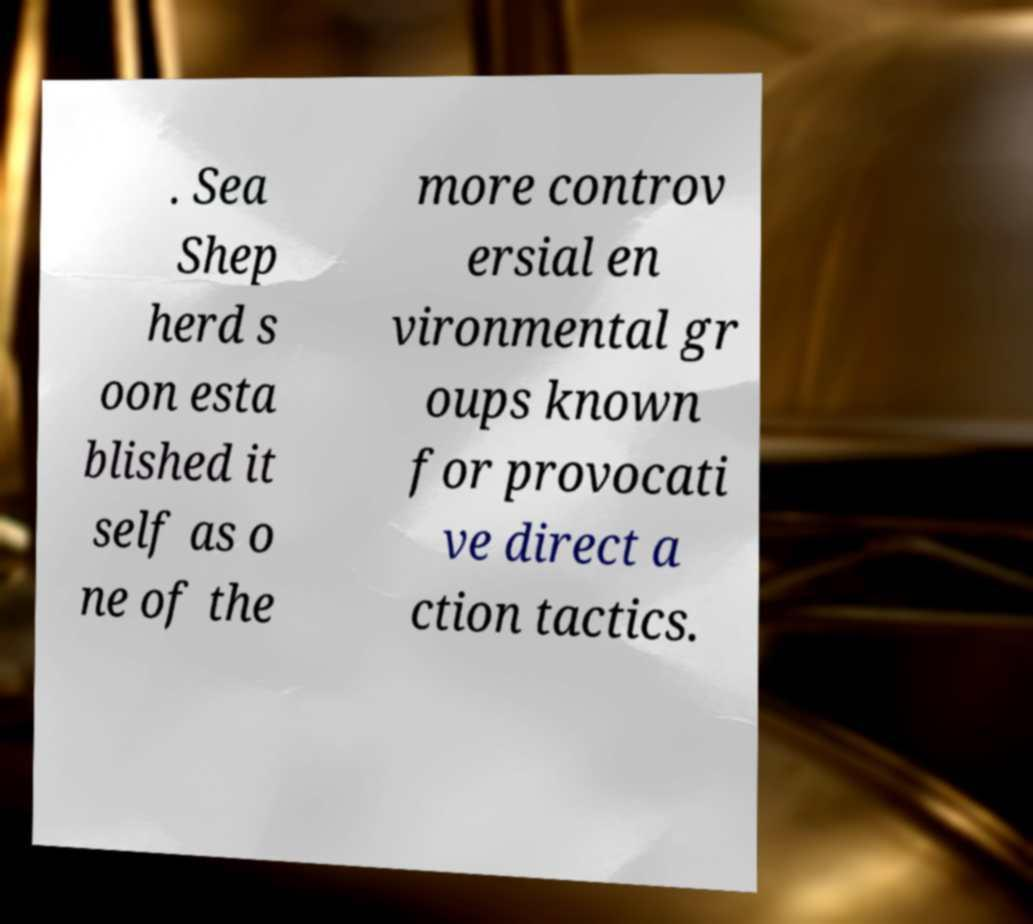Please identify and transcribe the text found in this image. . Sea Shep herd s oon esta blished it self as o ne of the more controv ersial en vironmental gr oups known for provocati ve direct a ction tactics. 